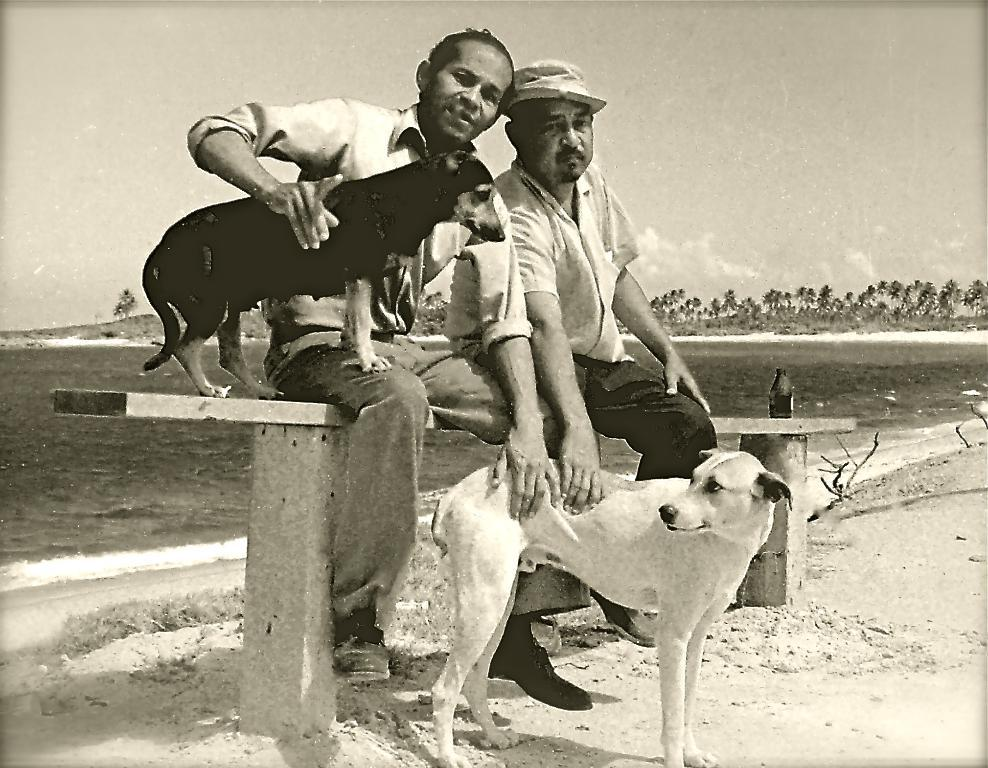How many people are in the image? There are two men in the image. What are the men doing in the image? The men are sitting on a bench. Is there any other living creature in the image besides the men? Yes, there is a dog in the image. What is the color scheme of the image? The image is in black and white color. What type of shoes is the dog wearing in the image? There are no shoes present in the image, as dogs do not wear shoes. 